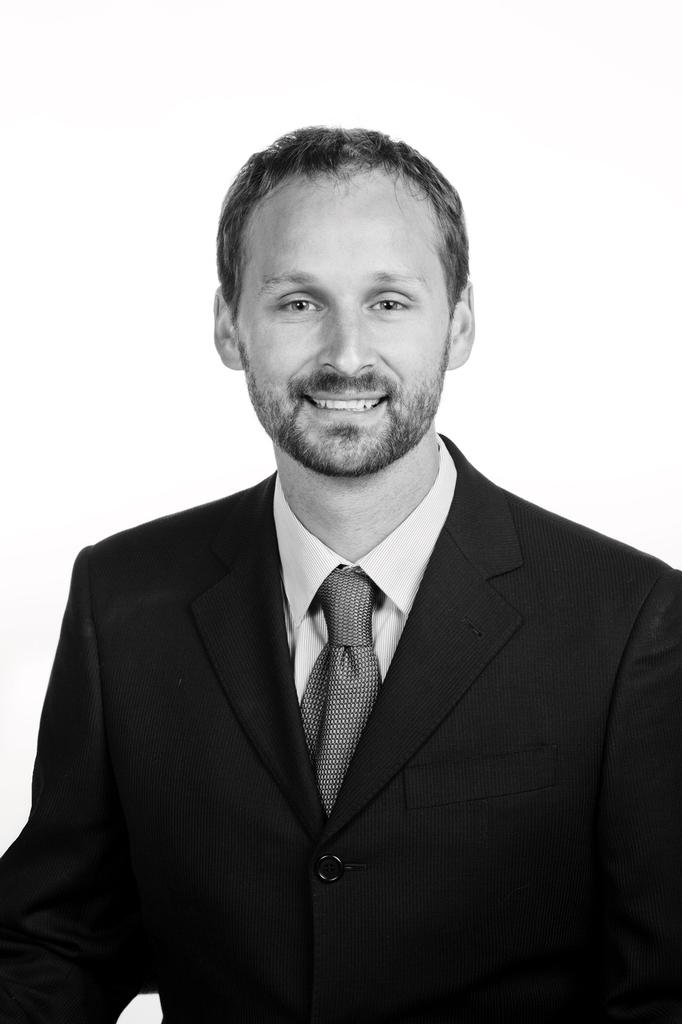Who is present in the image? There is a man in the image. What is the man's facial expression? The man is smiling. What color is the background of the image? The background of the image is white. What type of clam is being used as a prop in the image? There is no clam present in the image. How many nets are visible in the image? There are no nets visible in the image. 